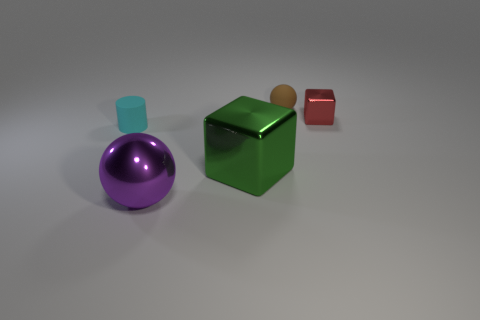Is there any other thing that has the same size as the green metallic cube?
Keep it short and to the point. Yes. There is a metal cube that is the same size as the purple object; what is its color?
Keep it short and to the point. Green. There is a big purple metal ball; what number of large purple metal spheres are to the left of it?
Make the answer very short. 0. Is there a red object that has the same material as the small cyan thing?
Ensure brevity in your answer.  No. There is a shiny cube in front of the cyan rubber cylinder; what is its color?
Your answer should be compact. Green. Are there the same number of purple spheres right of the green metallic cube and brown matte balls behind the cyan cylinder?
Your answer should be very brief. No. What is the large block that is left of the small rubber object on the right side of the small cyan object made of?
Offer a very short reply. Metal. What number of objects are small cyan objects or objects left of the brown matte thing?
Ensure brevity in your answer.  3. The green cube that is made of the same material as the purple thing is what size?
Offer a very short reply. Large. Is the number of small cyan rubber things that are to the right of the cyan matte thing greater than the number of red metal objects?
Keep it short and to the point. No. 